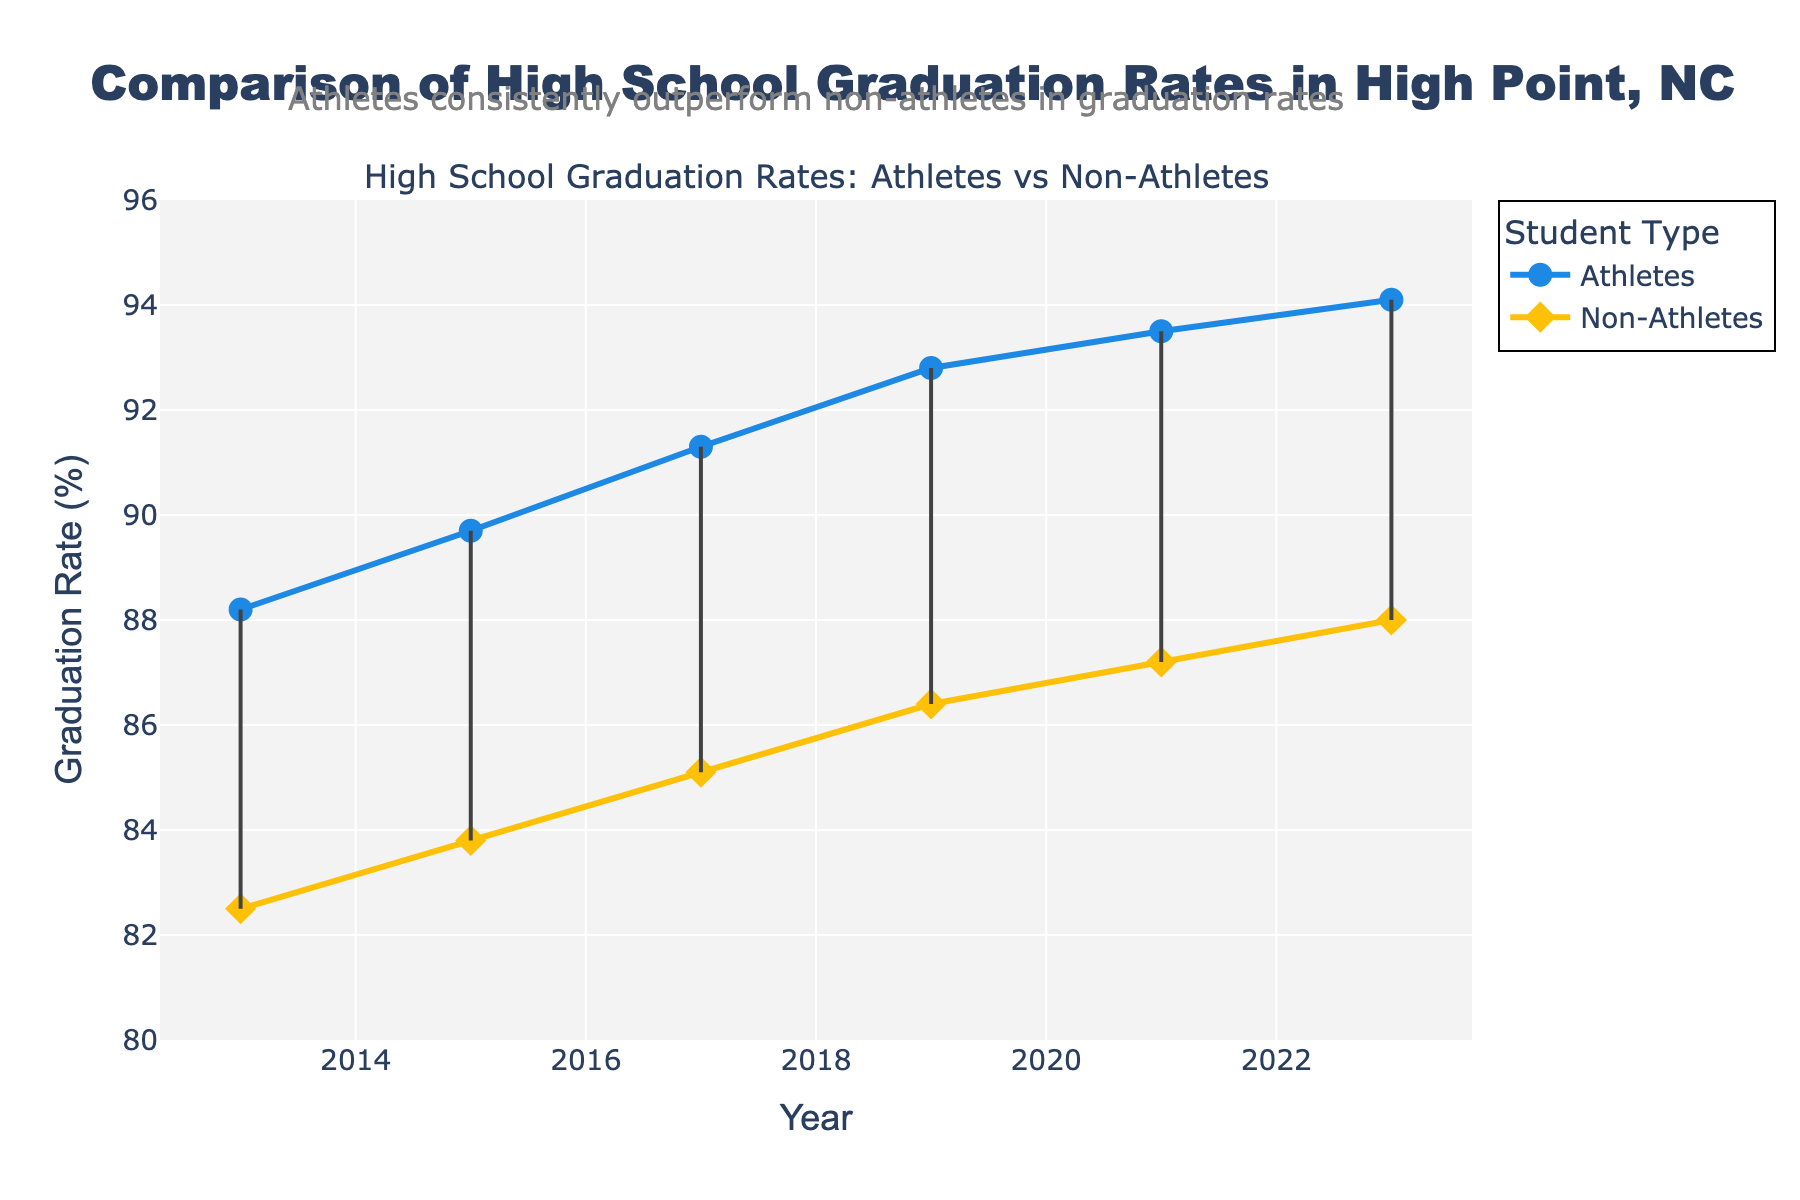What is the title of the plot? The title can be found at the top of the plot and is usually in larger and bold font.
Answer: Comparison of High School Graduation Rates in High Point, NC Which group had a higher graduation rate in 2023? By looking at the 2023 markers for both groups, you will see the athletes at 94.1% and non-athletes at 88.0%.
Answer: Athletes How many years of data are shown in the plot? Count the distinct markers or the x-axis labels representing the years.
Answer: 6 What is the graduation rate for non-athletes in 2015? Locate the 2015 year on the x-axis and trace upwards to the non-athlete line/marker (diamond shape).
Answer: 83.8% Which year shows the smallest gap between athletes' and non-athletes' graduation rates? The gap can be visualized by the length of the line connecting the athlete and non-athlete markers for each year. The year with the shortest line shows the smallest gap.
Answer: 2013 By how much did the athletes' graduation rate increase from 2013 to 2023? Subtract the 2013 graduation rate from the 2023 graduation rate for athletes: 94.1% - 88.2% = 5.9%.
Answer: 5.9% During which years did athletes’ graduation rates surpass 90%? Identify the years where the athletes' line rises above the 90% mark on the y-axis.
Answer: 2017, 2019, 2021, 2023 What is the average graduation rate of non-athletes over the years? The non-athletes' graduation rates over the years are: 82.5%, 83.8%, 85.1%, 86.4%, 87.2%, 88.0%. Sum these rates and divide by the number of years: (82.5 + 83.8 + 85.1 + 86.4 + 87.2 + 88.0) / 6 = 85.5%.
Answer: 85.5% Which group had a more significant improvement in graduation rates over the decade? Determine the rate of change for both groups from 2013 to 2023 by calculating the difference for each, and compare: Athletes: 94.1% - 88.2% = 5.9%, Non-Athletes: 88.0% - 82.5% = 5.5%. The athletes had a greater increase.
Answer: Athletes 